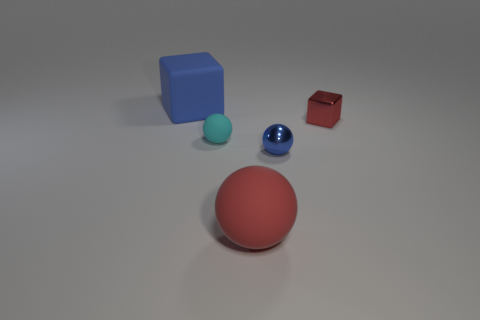Add 5 big red things. How many objects exist? 10 Subtract all balls. How many objects are left? 2 Subtract all tiny red metallic spheres. Subtract all blue rubber objects. How many objects are left? 4 Add 5 small blue spheres. How many small blue spheres are left? 6 Add 1 tiny blue shiny objects. How many tiny blue shiny objects exist? 2 Subtract 0 yellow cubes. How many objects are left? 5 